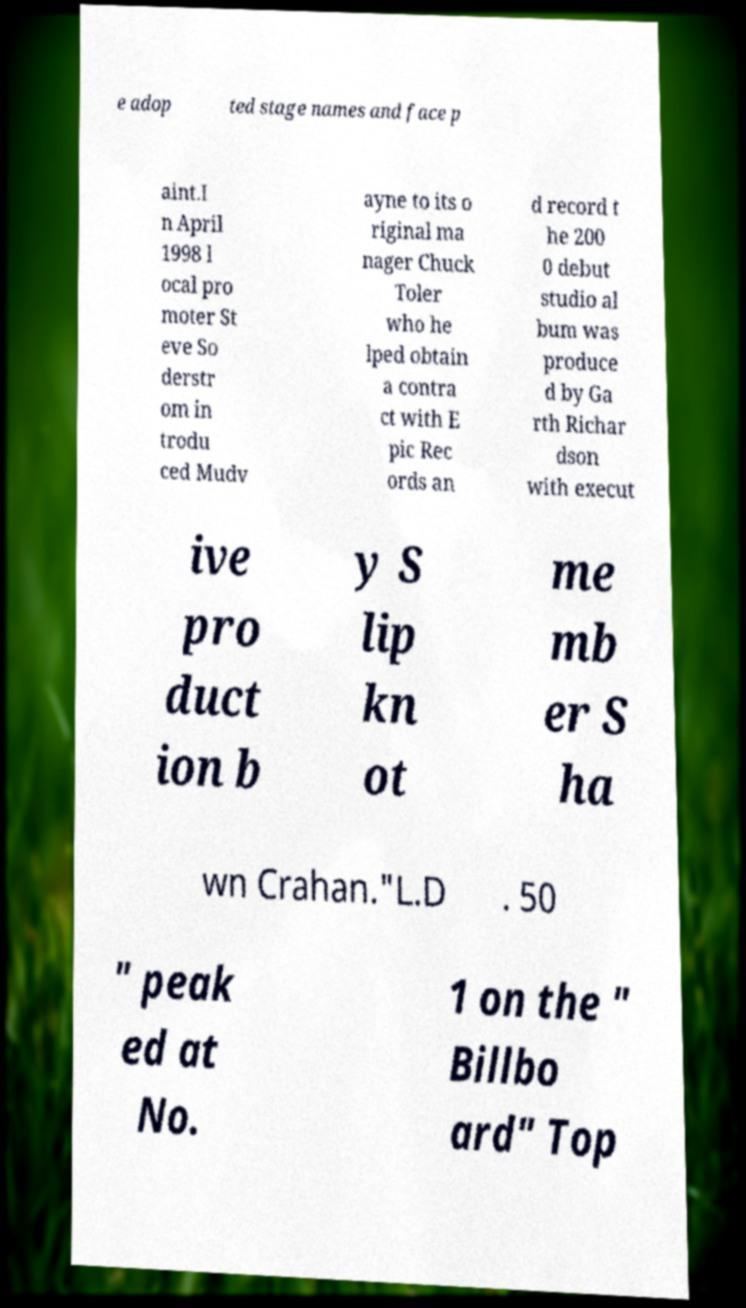There's text embedded in this image that I need extracted. Can you transcribe it verbatim? e adop ted stage names and face p aint.I n April 1998 l ocal pro moter St eve So derstr om in trodu ced Mudv ayne to its o riginal ma nager Chuck Toler who he lped obtain a contra ct with E pic Rec ords an d record t he 200 0 debut studio al bum was produce d by Ga rth Richar dson with execut ive pro duct ion b y S lip kn ot me mb er S ha wn Crahan."L.D . 50 " peak ed at No. 1 on the " Billbo ard" Top 